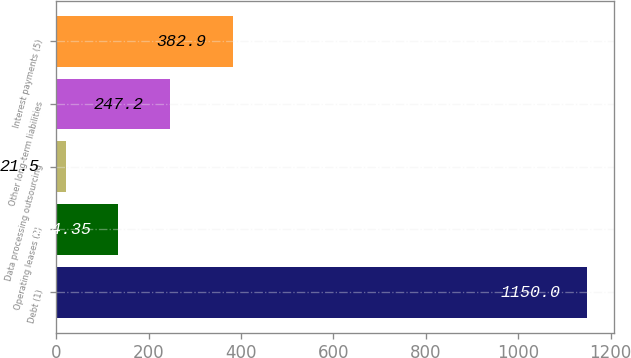Convert chart. <chart><loc_0><loc_0><loc_500><loc_500><bar_chart><fcel>Debt (1)<fcel>Operating leases (2)<fcel>Data processing outsourcing<fcel>Other long-term liabilities<fcel>Interest payments (5)<nl><fcel>1150<fcel>134.35<fcel>21.5<fcel>247.2<fcel>382.9<nl></chart> 